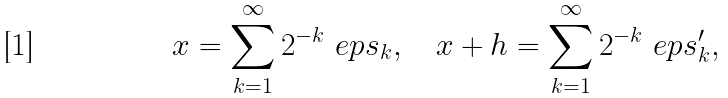Convert formula to latex. <formula><loc_0><loc_0><loc_500><loc_500>x = \sum _ { k = 1 } ^ { \infty } 2 ^ { - k } \ e p s _ { k } , \quad x + h = \sum _ { k = 1 } ^ { \infty } 2 ^ { - k } \ e p s _ { k } ^ { \prime } ,</formula> 